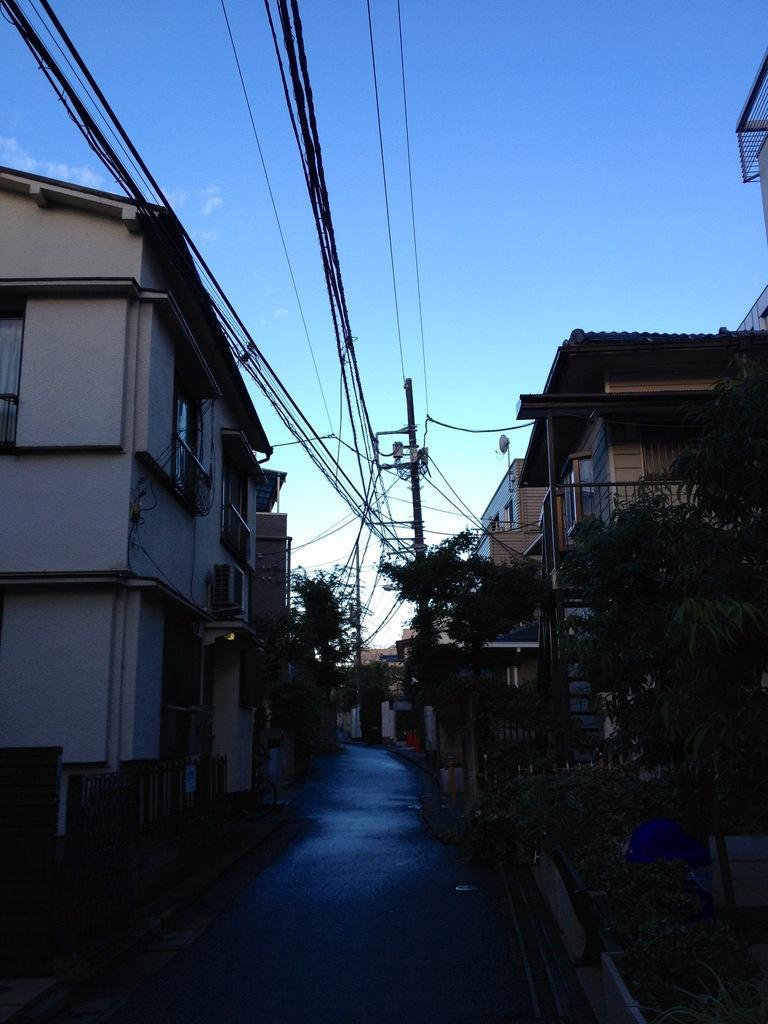How would you summarize this image in a sentence or two? It's a road in the middle of an image, there are houses on either side of this road. At the top it's a blue color sky. 